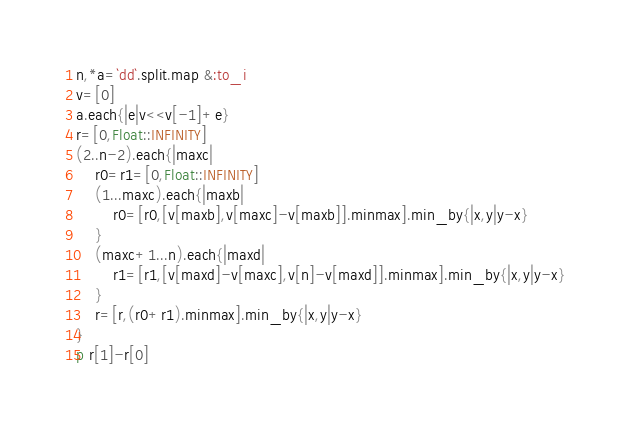Convert code to text. <code><loc_0><loc_0><loc_500><loc_500><_Ruby_>n,*a=`dd`.split.map &:to_i
v=[0]
a.each{|e|v<<v[-1]+e}
r=[0,Float::INFINITY]
(2..n-2).each{|maxc|
	r0=r1=[0,Float::INFINITY]
	(1...maxc).each{|maxb|
		r0=[r0,[v[maxb],v[maxc]-v[maxb]].minmax].min_by{|x,y|y-x}
	}
	(maxc+1...n).each{|maxd|
		r1=[r1,[v[maxd]-v[maxc],v[n]-v[maxd]].minmax].min_by{|x,y|y-x}
	}
	r=[r,(r0+r1).minmax].min_by{|x,y|y-x}
}
p r[1]-r[0]</code> 